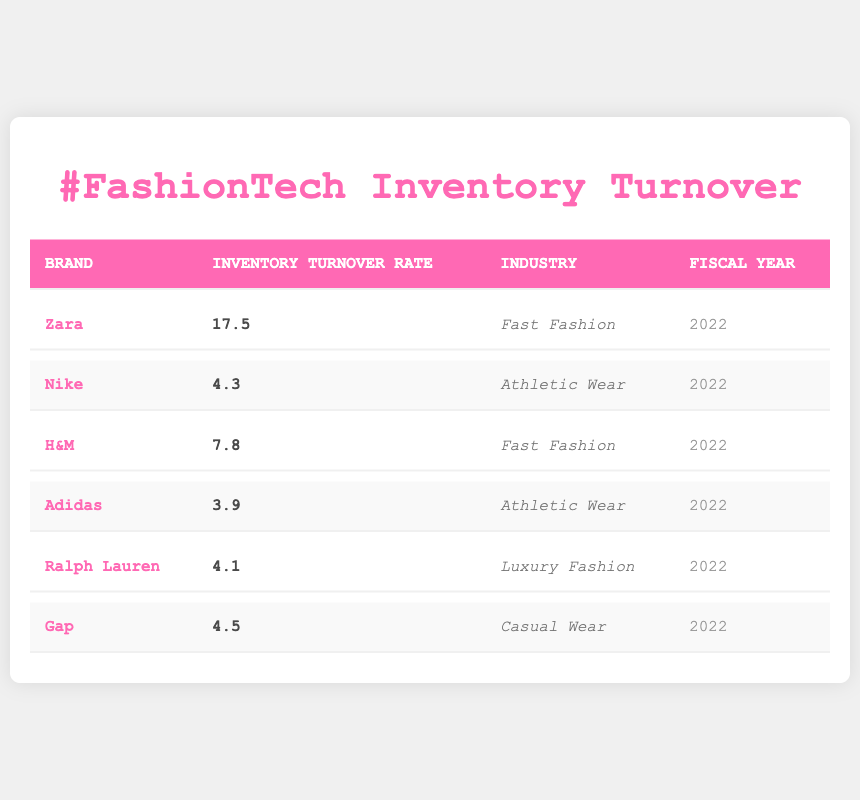What is the inventory turnover rate for Zara? The inventory turnover rate for Zara is listed directly in the table under the "Inventory Turnover Rate" column, which states 17.5 for the brand Zara.
Answer: 17.5 Which brand belongs to the Fast Fashion industry with the second highest turnover rate? From the table, I can see that Zara has the highest turnover rate in Fast Fashion (17.5), and H&M is the second highest with a turnover rate of 7.8.
Answer: H&M Is the inventory turnover rate for Nike higher than that for Adidas? The table shows that Nike has a turnover rate of 4.3 while Adidas has 3.9. Since 4.3 is greater than 3.9, the answer is yes.
Answer: Yes What is the average inventory turnover rate for the Athletic Wear industry? The turnover rates for Nike and Adidas are 4.3 and 3.9, respectively. The average is calculated by summing these rates (4.3 + 3.9) = 8.2, and then dividing by 2, resulting in 8.2 / 2 = 4.1.
Answer: 4.1 Which brand has the lowest inventory turnover rate among those listed? By comparing the turnover rates for each brand in the table, Adidas has the lowest turnover rate at 3.9.
Answer: Adidas Is there any brand in the Casual Wear industry that has a turnover rate above 5? According to the table, Gap, the only brand listed under Casual Wear, has a turnover rate of 4.5, which is below 5. Therefore, the answer is no.
Answer: No What is the difference in inventory turnover rates between the highest and lowest rated brands? Zara has the highest rate at 17.5 and Adidas has the lowest at 3.9. The difference is calculated as 17.5 - 3.9 = 13.6.
Answer: 13.6 Which industry has the highest maximum inventory turnover rate based on the table? The maximum turnover rate is from Zara in the Fast Fashion industry at 17.5, and no other industry listed has a brand with a higher turnover rate than this. Thus, Fast Fashion has the highest maximum inventory turnover rate.
Answer: Fast Fashion What fiscal year does the inventory turnover data apply to? All entries in the table denote the fiscal year 2022, as stated in the last column for each brand listed.
Answer: 2022 